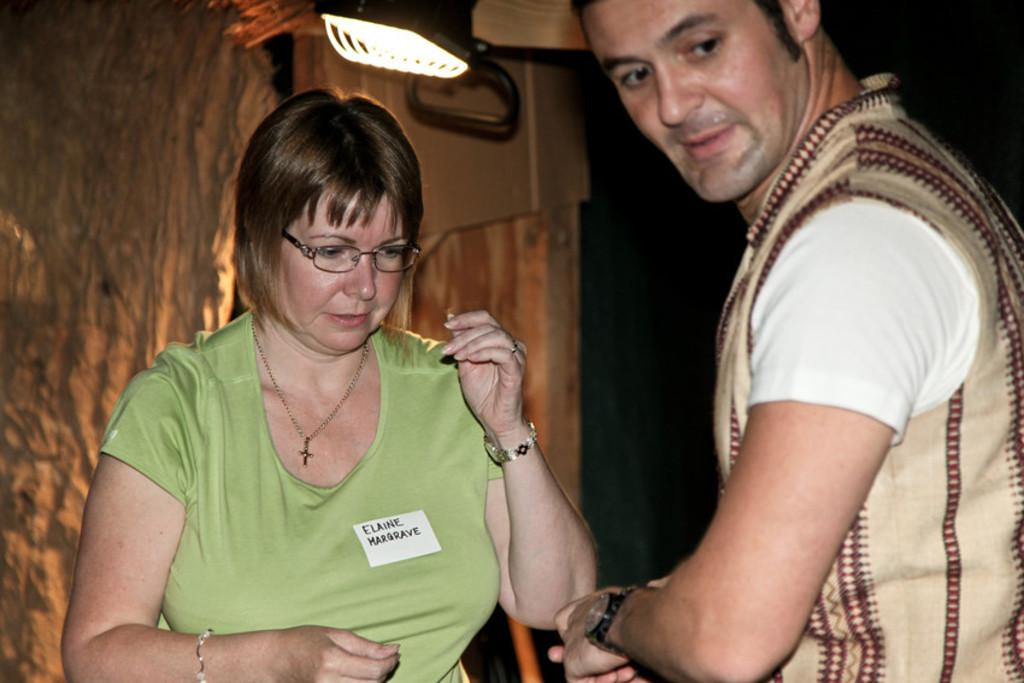Who are the people in the image? There is a man and a woman standing in the image. What are the man and woman wearing? The man and woman are wearing clothes. What accessories can be seen in the image? There is a wrist watch, a bracelet, a neck chain, and a finger ring in the image. What else can be seen in the image? There are spectacles and a light in the image. What type of fang can be seen in the image? There are no fangs present in the image. What kind of growth is visible on the man's head in the image? There is no growth visible on the man's head in the image. 